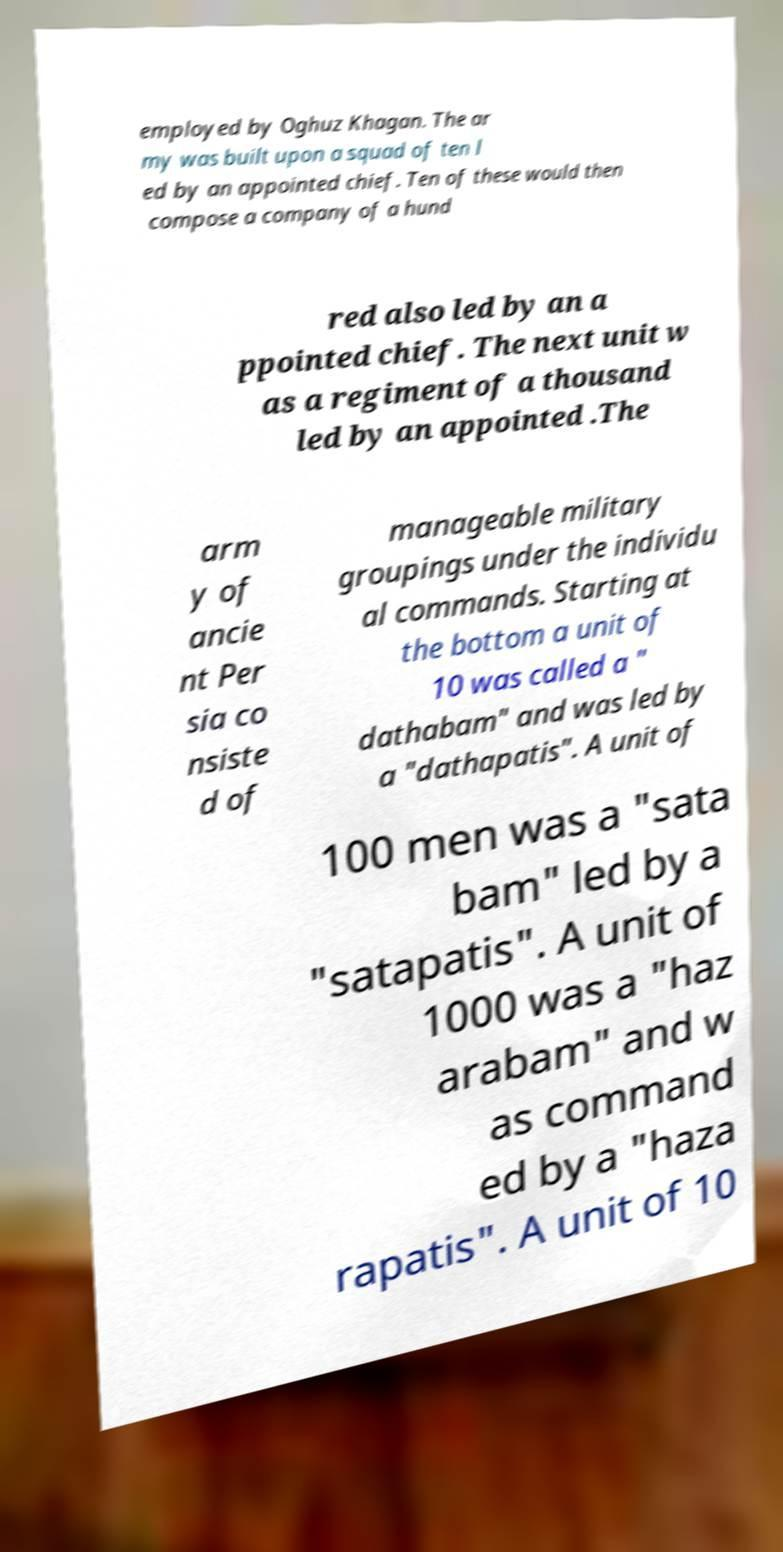Could you assist in decoding the text presented in this image and type it out clearly? employed by Oghuz Khagan. The ar my was built upon a squad of ten l ed by an appointed chief. Ten of these would then compose a company of a hund red also led by an a ppointed chief. The next unit w as a regiment of a thousand led by an appointed .The arm y of ancie nt Per sia co nsiste d of manageable military groupings under the individu al commands. Starting at the bottom a unit of 10 was called a " dathabam" and was led by a "dathapatis". A unit of 100 men was a "sata bam" led by a "satapatis". A unit of 1000 was a "haz arabam" and w as command ed by a "haza rapatis". A unit of 10 